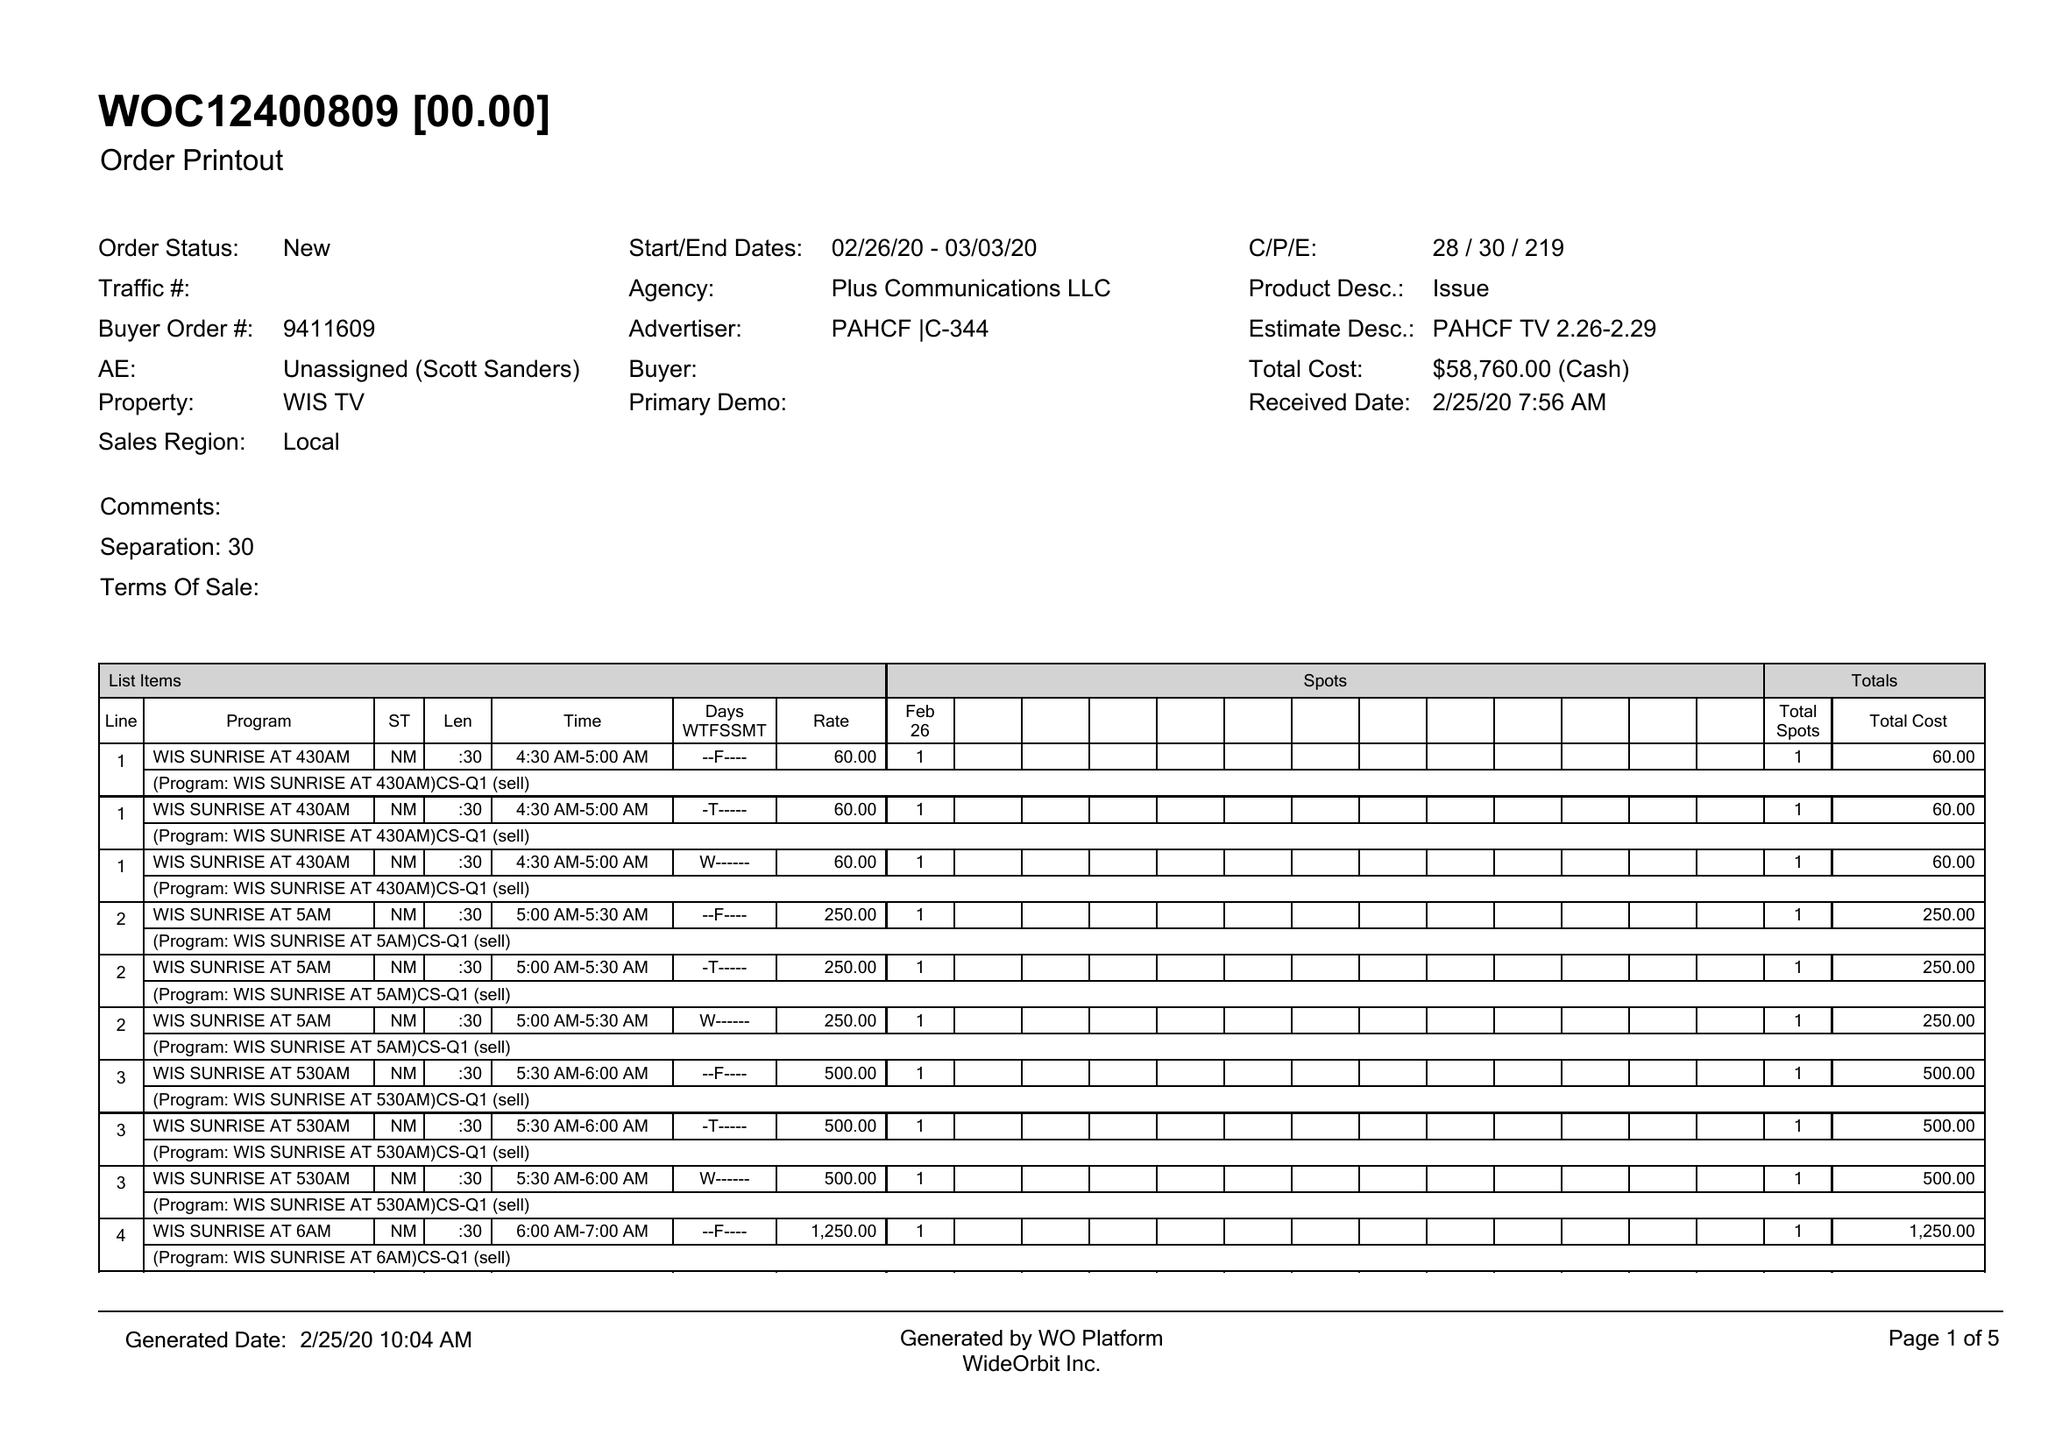What is the value for the flight_from?
Answer the question using a single word or phrase. 02/26/20 